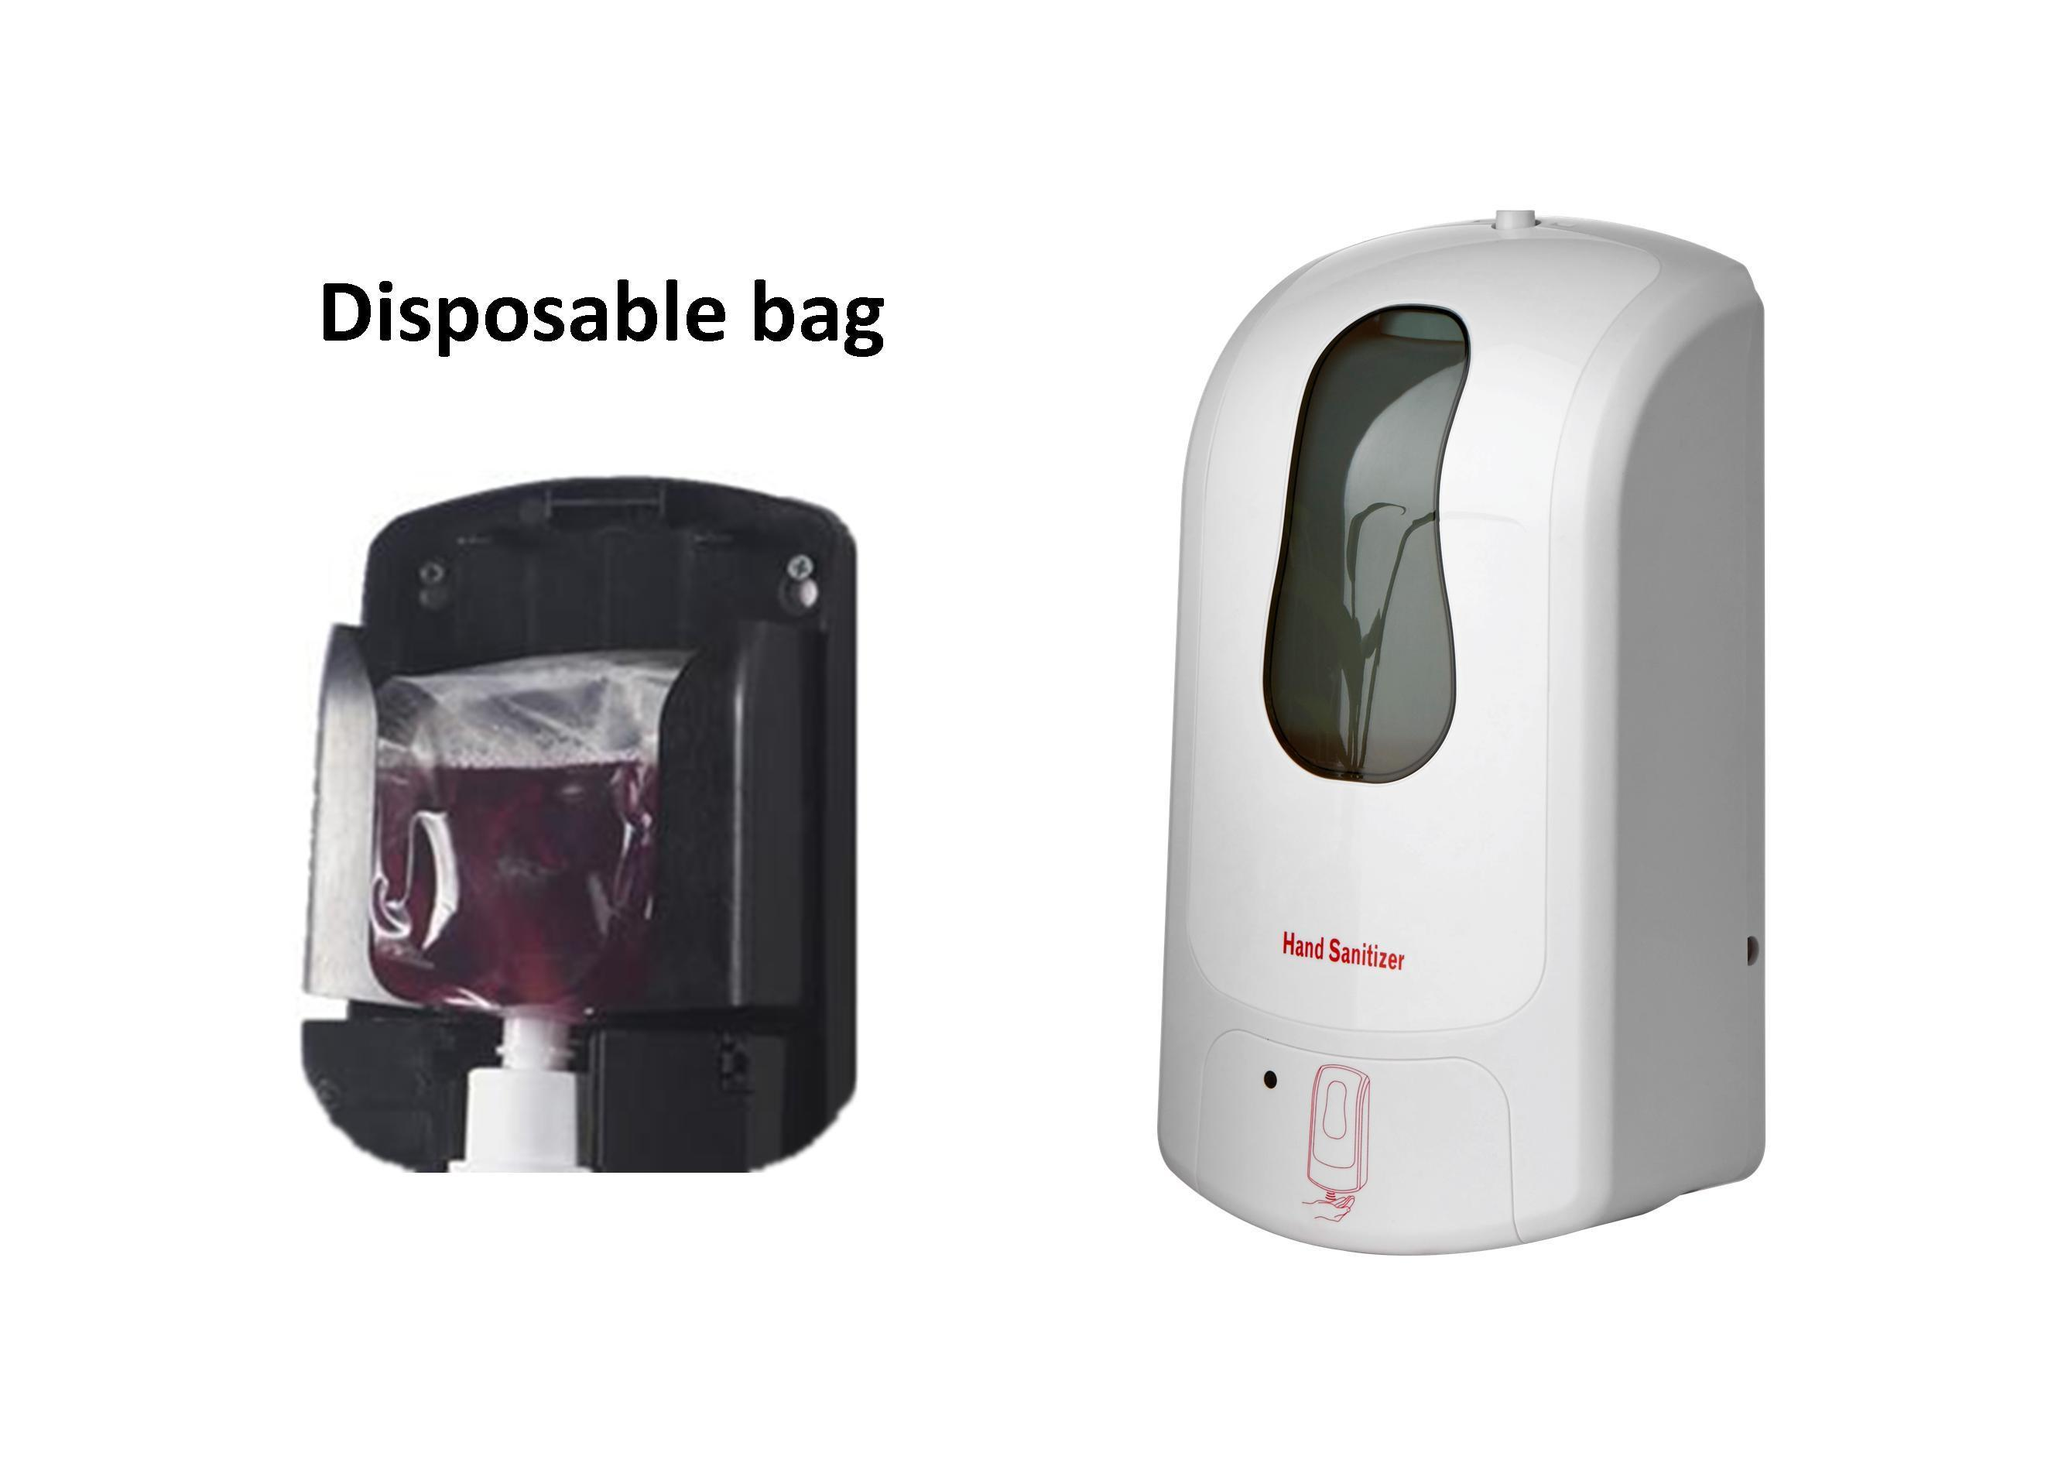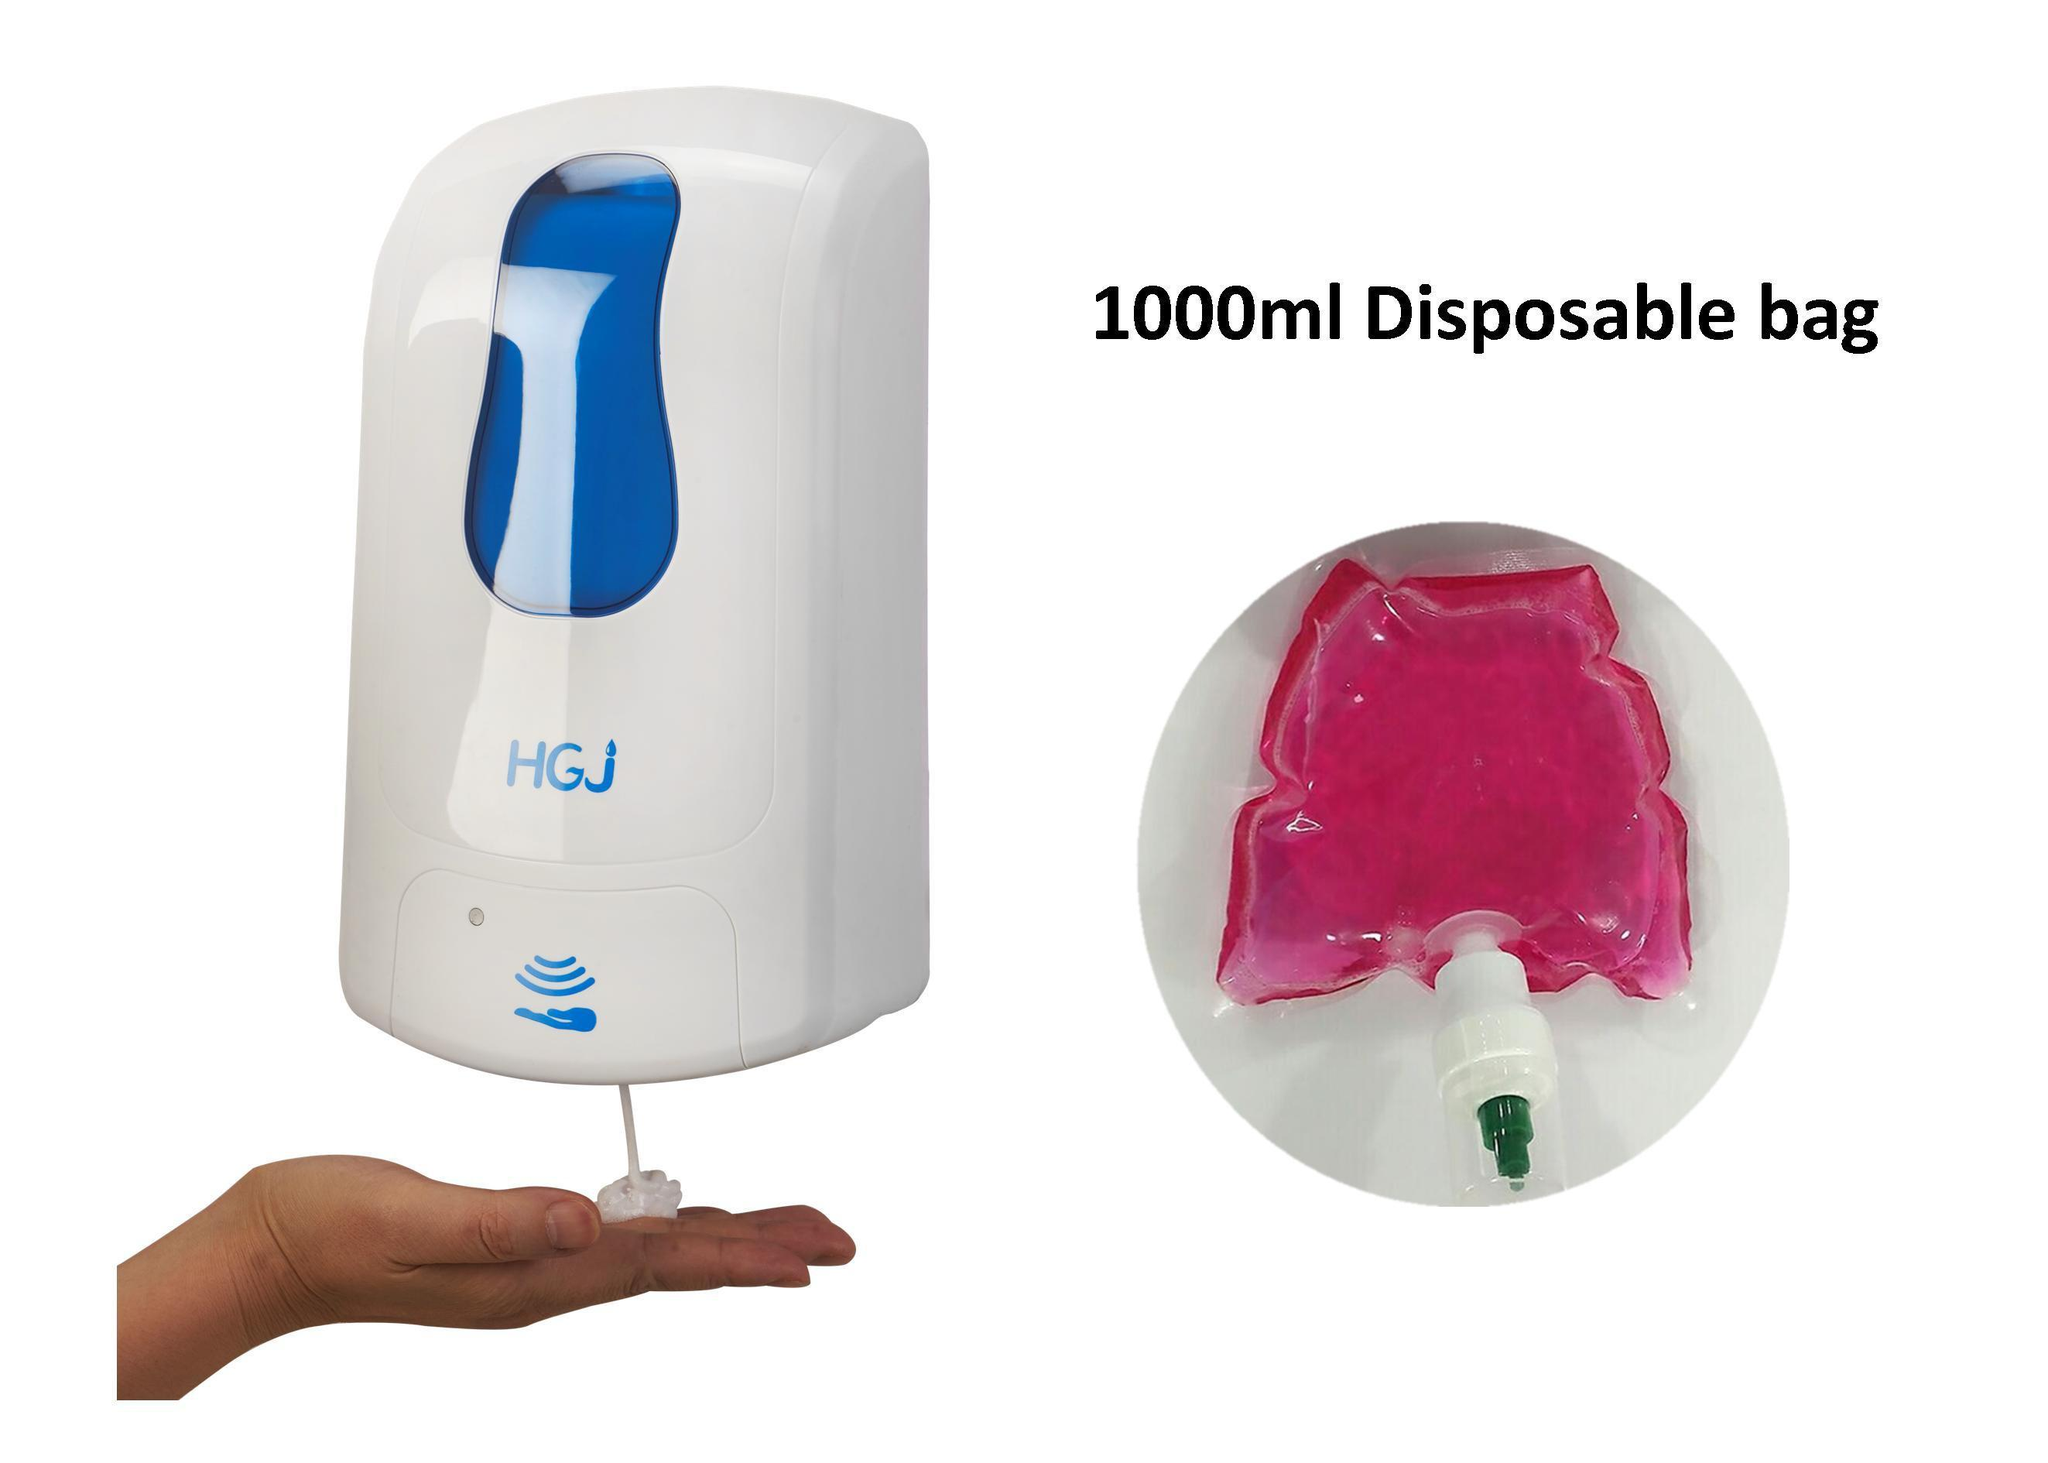The first image is the image on the left, the second image is the image on the right. Assess this claim about the two images: "in at least one image there are three wall soap dispensers.". Correct or not? Answer yes or no. No. 